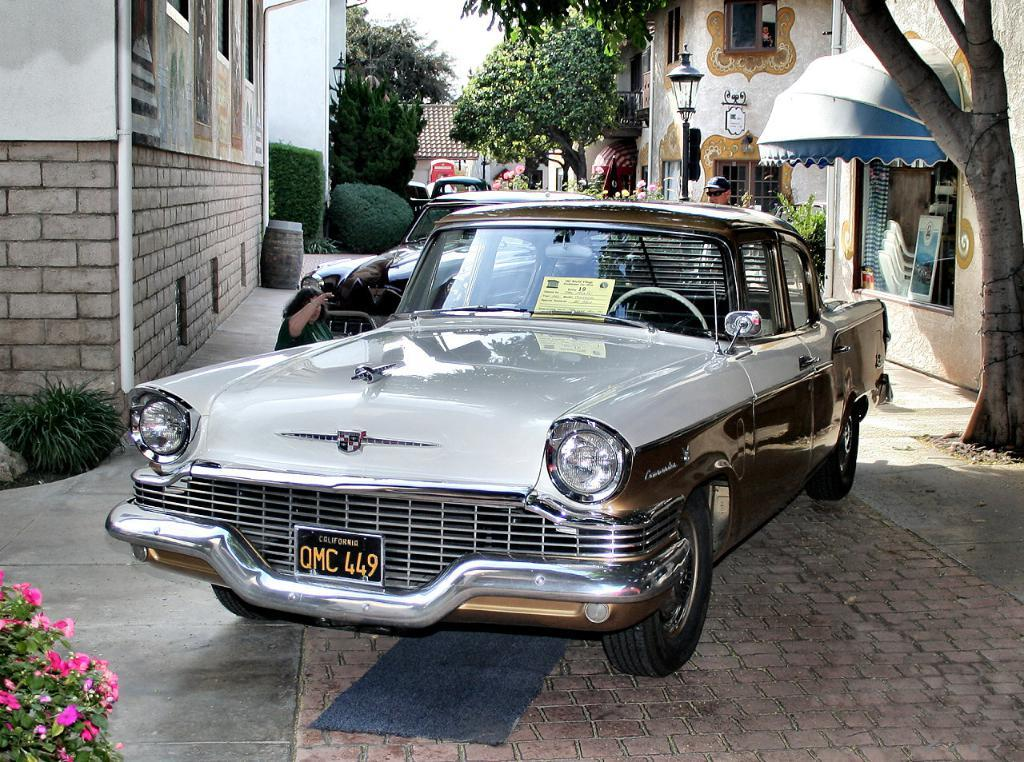What types of objects can be seen in the image? There are vehicles, buildings, poles, lights, trees, plants, chairs, and persons in the image. Can you describe the environment in the image? The image features a mix of urban and natural elements, including buildings, trees, and plants. What is visible in the background of the image? The sky is visible in the background of the image. How many types of objects can be seen in the image? There are nine types of objects in the image: vehicles, buildings, poles, lights, trees, plants, chairs, and persons. Where is the cobweb located in the image? There is no cobweb present in the image. What sound does the bell make in the image? There is no bell present in the image. 